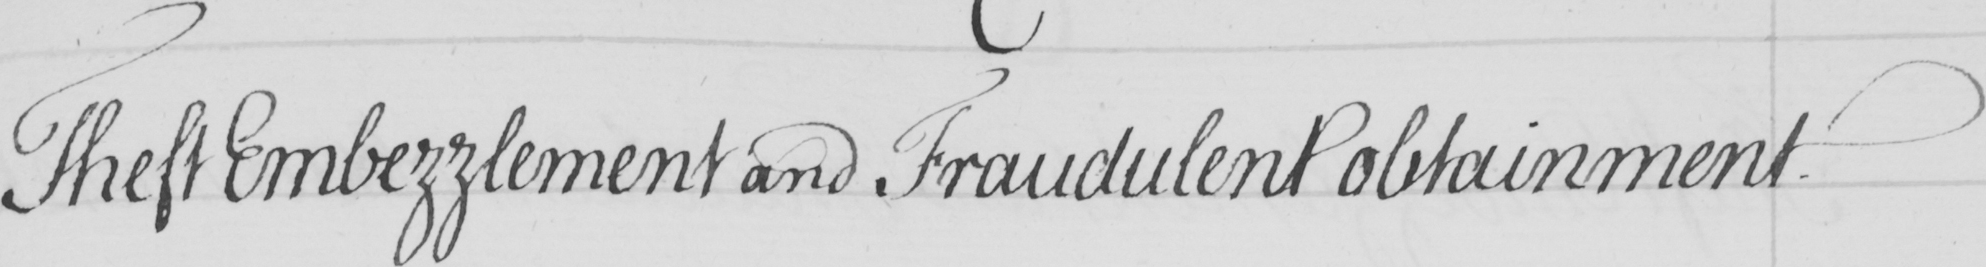Can you read and transcribe this handwriting? Theft Embezzlement and Fraudulent Obtainment 